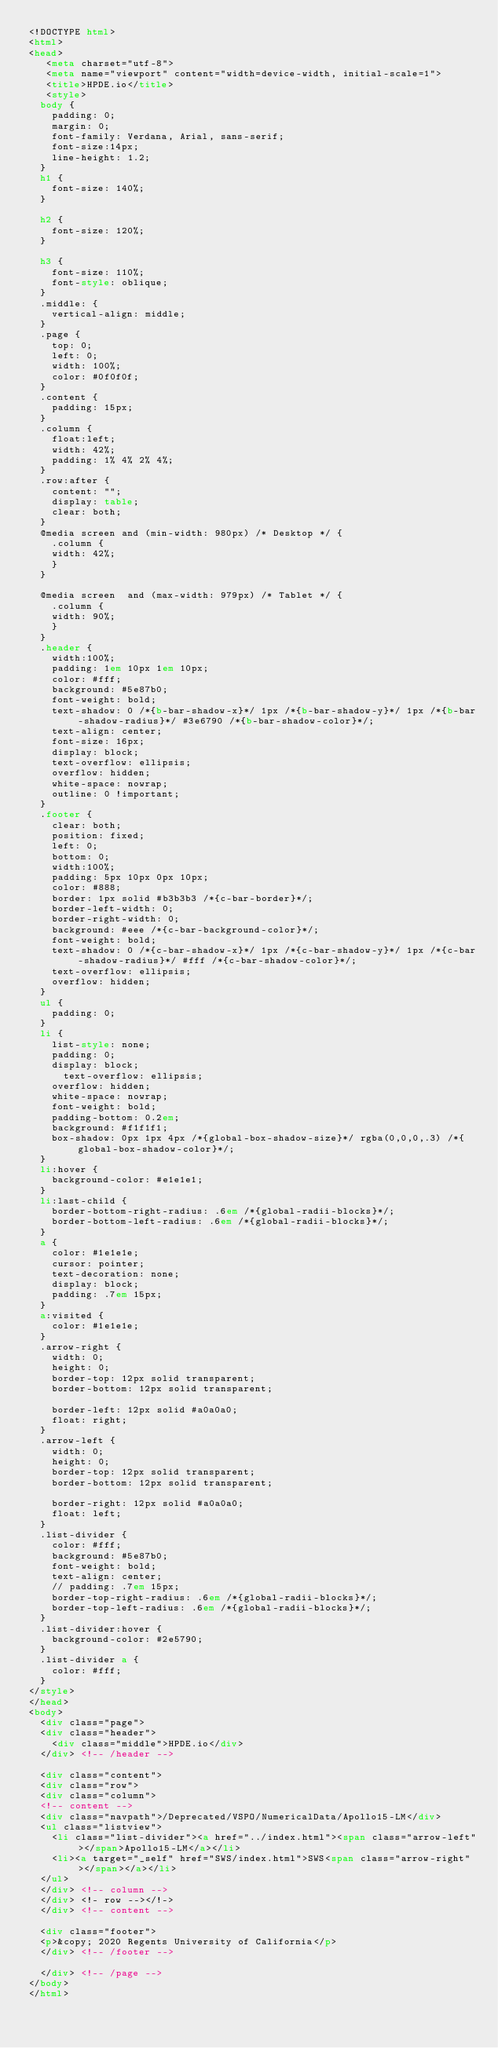Convert code to text. <code><loc_0><loc_0><loc_500><loc_500><_HTML_><!DOCTYPE html>
<html>
<head>
   <meta charset="utf-8">
   <meta name="viewport" content="width=device-width, initial-scale=1">
   <title>HPDE.io</title>
   <style>
	body {
		padding: 0;
		margin: 0;
		font-family: Verdana, Arial, sans-serif; 
		font-size:14px; 
		line-height: 1.2;
	}
	h1 {
		font-size: 140%;
	}

	h2 {
		font-size: 120%;
	}

	h3 {
		font-size: 110%;
		font-style: oblique;
	}
	.middle: {
		vertical-align: middle;
	}
	.page {
		top: 0;
		left: 0;
		width: 100%;
		color: #0f0f0f;
	}
	.content {
		padding: 15px;
	}
	.column {
		float:left;
		width: 42%;
		padding: 1% 4% 2% 4%;
	}
	.row:after {
		content: "";
		display: table;
		clear: both;
	}	
	@media screen and (min-width: 980px) /* Desktop */ {
	  .column {
		width: 42%;
	  }
	}

	@media screen  and (max-width: 979px) /* Tablet */ {
	  .column {
		width: 90%;
	  }
	}
	.header {
		width:100%;
		padding: 1em 10px 1em 10px;
		color: #fff;
		background: #5e87b0;
		font-weight: bold;
		text-shadow: 0 /*{b-bar-shadow-x}*/ 1px /*{b-bar-shadow-y}*/ 1px /*{b-bar-shadow-radius}*/ #3e6790 /*{b-bar-shadow-color}*/;
		text-align: center;
		font-size: 16px;
		display: block;
		text-overflow: ellipsis;
		overflow: hidden;
		white-space: nowrap;
		outline: 0 !important;
	}
	.footer {
		clear: both;
		position: fixed;
		left: 0;
		bottom: 0;
		width:100%;
		padding: 5px 10px 0px 10px;
		color: #888;
		border: 1px solid #b3b3b3 /*{c-bar-border}*/;
		border-left-width: 0;
		border-right-width: 0;
		background: #eee /*{c-bar-background-color}*/;
		font-weight: bold;
		text-shadow: 0 /*{c-bar-shadow-x}*/ 1px /*{c-bar-shadow-y}*/ 1px /*{c-bar-shadow-radius}*/ #fff /*{c-bar-shadow-color}*/;
		text-overflow: ellipsis;
		overflow: hidden;
	}
	ul {
		padding: 0;
	}
	li {
		list-style: none;
		padding: 0;
		display: block;
	    text-overflow: ellipsis;
		overflow: hidden;
		white-space: nowrap;
		font-weight: bold;
		padding-bottom: 0.2em;
		background: #f1f1f1;
		box-shadow: 0px 1px 4px /*{global-box-shadow-size}*/ rgba(0,0,0,.3) /*{global-box-shadow-color}*/;
	}
	li:hover {
		background-color: #e1e1e1;
	}
	li:last-child {
		border-bottom-right-radius: .6em /*{global-radii-blocks}*/;
		border-bottom-left-radius: .6em /*{global-radii-blocks}*/;
	}
	a {
		color: #1e1e1e;
		cursor: pointer;
		text-decoration: none;
		display: block;
		padding: .7em 15px;
	}
	a:visited {
		color: #1e1e1e;
	}
	.arrow-right {
	  width: 0; 
	  height: 0; 
	  border-top: 12px solid transparent;
	  border-bottom: 12px solid transparent;
	  
	  border-left: 12px solid #a0a0a0;
	  float: right;
	}
	.arrow-left {
	  width: 0; 
	  height: 0; 
	  border-top: 12px solid transparent;
	  border-bottom: 12px solid transparent;
	  
	  border-right: 12px solid #a0a0a0;
	  float: left;
	}
	.list-divider {
		color: #fff;
		background: #5e87b0;
		font-weight: bold;
		text-align: center;
		// padding: .7em 15px;
		border-top-right-radius: .6em /*{global-radii-blocks}*/;
		border-top-left-radius: .6em /*{global-radii-blocks}*/;
	}
	.list-divider:hover {
		background-color: #2e5790;
	}
	.list-divider a {
		color: #fff;
	}
</style>
</head>
<body>
	<div class="page">
	<div class="header">
		<div class="middle">HPDE.io</div>
	</div> <!-- /header -->
	
	<div class="content">
	<div class="row">
	<div class="column">
	<!-- content -->
	<div class="navpath">/Deprecated/VSPO/NumericalData/Apollo15-LM</div>
	<ul class="listview">
		<li class="list-divider"><a href="../index.html"><span class="arrow-left"></span>Apollo15-LM</a></li>
		<li><a target="_self" href="SWS/index.html">SWS<span class="arrow-right"></span></a></li>
	</ul>
	</div> <!-- column -->
	</div> <!- row --></!->
	</div> <!-- content -->
	
	<div class="footer">
	<p>&copy; 2020 Regents University of California</p>
	</div> <!-- /footer -->
	
	</div> <!-- /page -->
</body>
</html></code> 